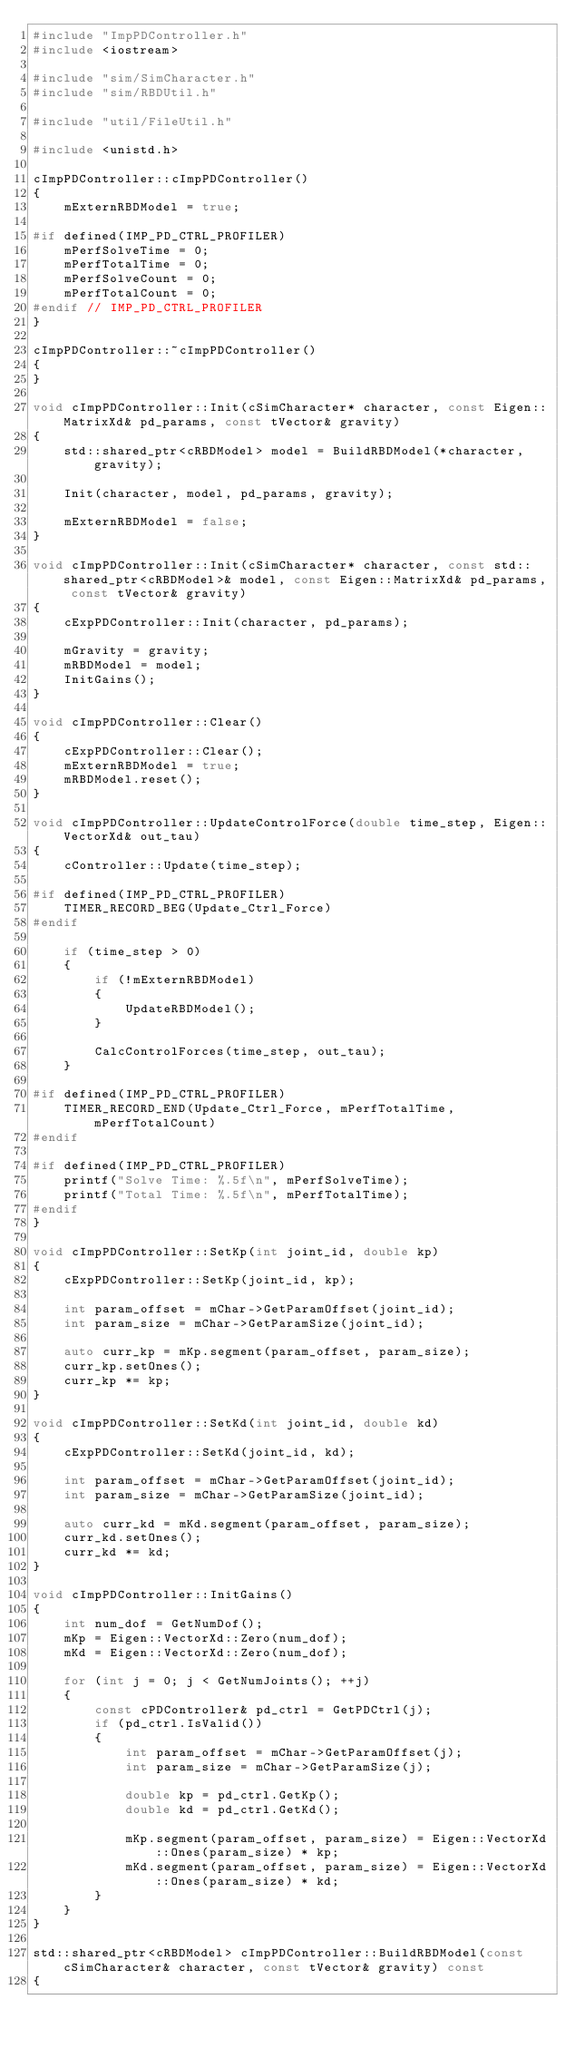Convert code to text. <code><loc_0><loc_0><loc_500><loc_500><_C++_>#include "ImpPDController.h"
#include <iostream>

#include "sim/SimCharacter.h"
#include "sim/RBDUtil.h"

#include "util/FileUtil.h"

#include <unistd.h>

cImpPDController::cImpPDController()
{
	mExternRBDModel = true;

#if defined(IMP_PD_CTRL_PROFILER)
	mPerfSolveTime = 0;
	mPerfTotalTime = 0;
	mPerfSolveCount = 0;
	mPerfTotalCount = 0;
#endif // IMP_PD_CTRL_PROFILER
}

cImpPDController::~cImpPDController()
{
}

void cImpPDController::Init(cSimCharacter* character, const Eigen::MatrixXd& pd_params, const tVector& gravity)
{
	std::shared_ptr<cRBDModel> model = BuildRBDModel(*character, gravity);

	Init(character, model, pd_params, gravity);

	mExternRBDModel = false;
}

void cImpPDController::Init(cSimCharacter* character, const std::shared_ptr<cRBDModel>& model, const Eigen::MatrixXd& pd_params, const tVector& gravity)
{
	cExpPDController::Init(character, pd_params);

	mGravity = gravity;
	mRBDModel = model;
	InitGains();
}

void cImpPDController::Clear()
{
	cExpPDController::Clear();
	mExternRBDModel = true;
	mRBDModel.reset();
}

void cImpPDController::UpdateControlForce(double time_step, Eigen::VectorXd& out_tau)
{
	cController::Update(time_step);

#if defined(IMP_PD_CTRL_PROFILER)
	TIMER_RECORD_BEG(Update_Ctrl_Force)
#endif

	if (time_step > 0)
	{
		if (!mExternRBDModel)
		{
			UpdateRBDModel();
		}

		CalcControlForces(time_step, out_tau);
	}

#if defined(IMP_PD_CTRL_PROFILER)
	TIMER_RECORD_END(Update_Ctrl_Force, mPerfTotalTime, mPerfTotalCount)
#endif

#if defined(IMP_PD_CTRL_PROFILER)
	printf("Solve Time: %.5f\n", mPerfSolveTime);
	printf("Total Time: %.5f\n", mPerfTotalTime);
#endif
}

void cImpPDController::SetKp(int joint_id, double kp)
{
	cExpPDController::SetKp(joint_id, kp);

	int param_offset = mChar->GetParamOffset(joint_id);
	int param_size = mChar->GetParamSize(joint_id);

	auto curr_kp = mKp.segment(param_offset, param_size);
	curr_kp.setOnes();
	curr_kp *= kp;
}

void cImpPDController::SetKd(int joint_id, double kd)
{
	cExpPDController::SetKd(joint_id, kd);

	int param_offset = mChar->GetParamOffset(joint_id);
	int param_size = mChar->GetParamSize(joint_id);

	auto curr_kd = mKd.segment(param_offset, param_size);
	curr_kd.setOnes();
	curr_kd *= kd;
}

void cImpPDController::InitGains()
{
	int num_dof = GetNumDof();
	mKp = Eigen::VectorXd::Zero(num_dof);
	mKd = Eigen::VectorXd::Zero(num_dof);

	for (int j = 0; j < GetNumJoints(); ++j)
	{
		const cPDController& pd_ctrl = GetPDCtrl(j);
		if (pd_ctrl.IsValid())
		{
			int param_offset = mChar->GetParamOffset(j);
			int param_size = mChar->GetParamSize(j);

			double kp = pd_ctrl.GetKp();
			double kd = pd_ctrl.GetKd();

			mKp.segment(param_offset, param_size) = Eigen::VectorXd::Ones(param_size) * kp;
			mKd.segment(param_offset, param_size) = Eigen::VectorXd::Ones(param_size) * kd;
		}
	}
}

std::shared_ptr<cRBDModel> cImpPDController::BuildRBDModel(const cSimCharacter& character, const tVector& gravity) const
{</code> 